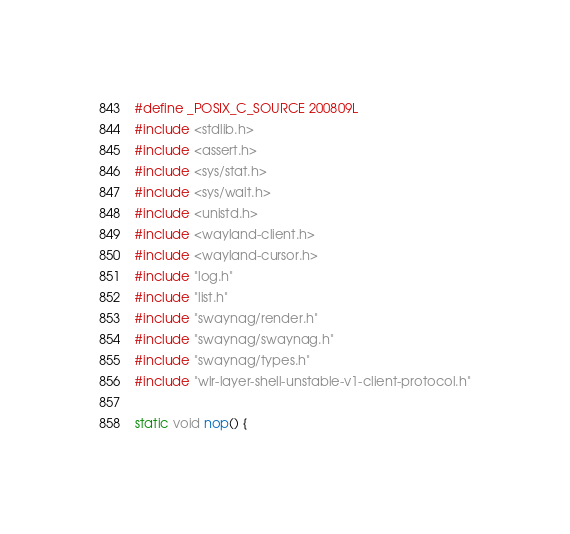<code> <loc_0><loc_0><loc_500><loc_500><_C_>#define _POSIX_C_SOURCE 200809L
#include <stdlib.h>
#include <assert.h>
#include <sys/stat.h>
#include <sys/wait.h>
#include <unistd.h>
#include <wayland-client.h>
#include <wayland-cursor.h>
#include "log.h"
#include "list.h"
#include "swaynag/render.h"
#include "swaynag/swaynag.h"
#include "swaynag/types.h"
#include "wlr-layer-shell-unstable-v1-client-protocol.h"

static void nop() {</code> 